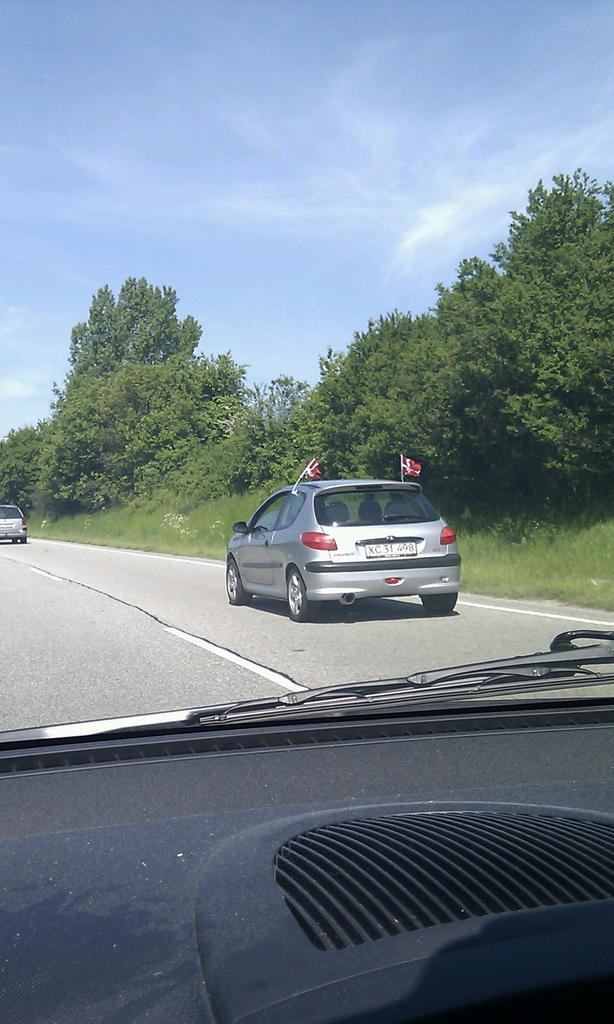What is the perspective of the image? The image is taken from a car. What can be seen on the road in the image? There are cars on the road in the image. What type of vegetation is visible in the image? There are trees visible at the back of the image. What is visible at the top of the image? The sky is visible at the top of the image. What type of wood can be seen in the image? There is no wood present in the image. What is the secretary doing in the image? There is no secretary present in the image. 